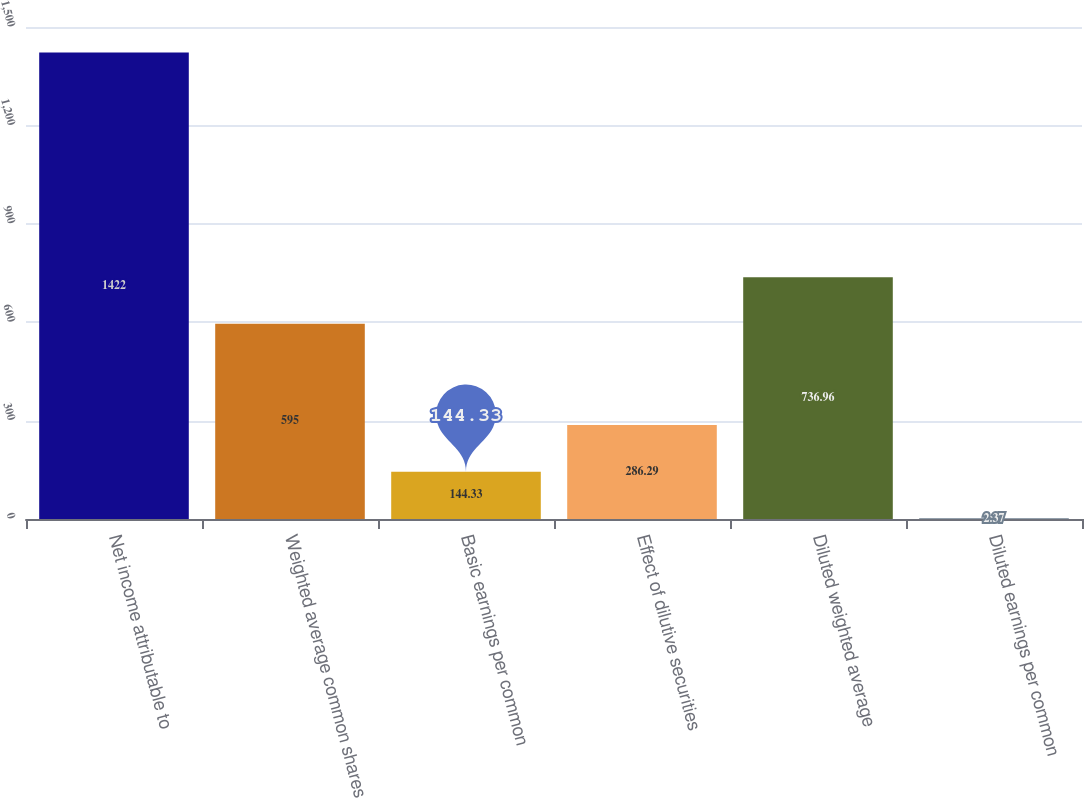Convert chart. <chart><loc_0><loc_0><loc_500><loc_500><bar_chart><fcel>Net income attributable to<fcel>Weighted average common shares<fcel>Basic earnings per common<fcel>Effect of dilutive securities<fcel>Diluted weighted average<fcel>Diluted earnings per common<nl><fcel>1422<fcel>595<fcel>144.33<fcel>286.29<fcel>736.96<fcel>2.37<nl></chart> 